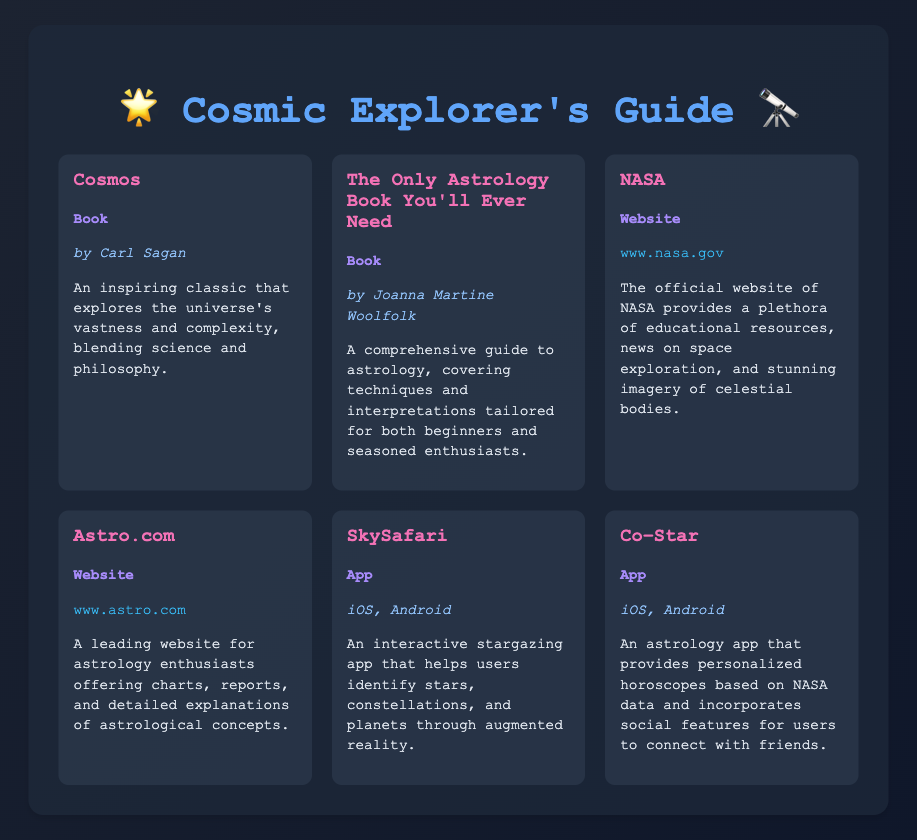What is the title of the first book listed? The first book listed is titled "Cosmos."
Answer: Cosmos Who is the author of "The Only Astrology Book You'll Ever Need"? The author of "The Only Astrology Book You'll Ever Need" is Joanna Martine Woolfolk.
Answer: Joanna Martine Woolfolk What is the type of the resource "NASA"? The type of the resource "NASA" is a website.
Answer: Website Which app is designed for stargazing? The app designed for stargazing is "SkySafari."
Answer: SkySafari How many apps are mentioned in the document? There are two apps mentioned in the document, which are "SkySafari" and "Co–Star."
Answer: Two What does the website Astro.com offer? Astro.com offers charts, reports, and detailed explanations of astrological concepts.
Answer: Charts, reports, and detailed explanations What platforms are compatible with the "Co–Star" app? The compatible platforms for the "Co–Star" app are iOS and Android.
Answer: iOS, Android Which resource blends science and philosophy? The resource that blends science and philosophy is "Cosmos."
Answer: Cosmos What is the primary educational focus of NASA? The primary educational focus of NASA is space exploration and celestial imagery.
Answer: Space exploration and celestial imagery 